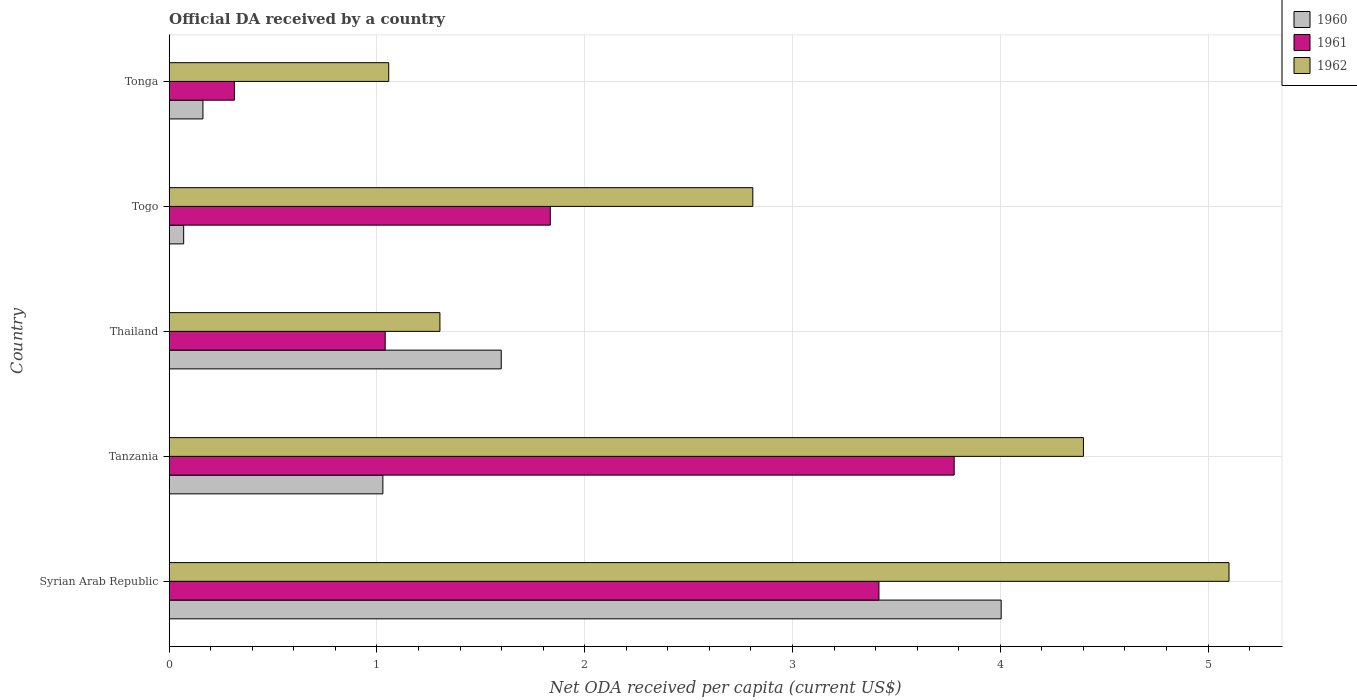Are the number of bars per tick equal to the number of legend labels?
Your response must be concise. Yes. Are the number of bars on each tick of the Y-axis equal?
Offer a terse response. Yes. What is the label of the 3rd group of bars from the top?
Keep it short and to the point. Thailand. What is the ODA received in in 1960 in Tonga?
Your response must be concise. 0.16. Across all countries, what is the maximum ODA received in in 1961?
Provide a short and direct response. 3.78. Across all countries, what is the minimum ODA received in in 1960?
Ensure brevity in your answer.  0.07. In which country was the ODA received in in 1960 maximum?
Offer a terse response. Syrian Arab Republic. In which country was the ODA received in in 1962 minimum?
Provide a succinct answer. Tonga. What is the total ODA received in in 1961 in the graph?
Provide a short and direct response. 10.38. What is the difference between the ODA received in in 1960 in Thailand and that in Tonga?
Your answer should be compact. 1.44. What is the difference between the ODA received in in 1962 in Tonga and the ODA received in in 1961 in Togo?
Offer a terse response. -0.78. What is the average ODA received in in 1960 per country?
Provide a succinct answer. 1.37. What is the difference between the ODA received in in 1961 and ODA received in in 1962 in Tonga?
Your response must be concise. -0.74. In how many countries, is the ODA received in in 1960 greater than 0.6000000000000001 US$?
Offer a very short reply. 3. What is the ratio of the ODA received in in 1961 in Syrian Arab Republic to that in Tanzania?
Offer a very short reply. 0.9. Is the ODA received in in 1962 in Syrian Arab Republic less than that in Togo?
Make the answer very short. No. What is the difference between the highest and the second highest ODA received in in 1960?
Offer a very short reply. 2.41. What is the difference between the highest and the lowest ODA received in in 1962?
Make the answer very short. 4.04. In how many countries, is the ODA received in in 1961 greater than the average ODA received in in 1961 taken over all countries?
Keep it short and to the point. 2. Are all the bars in the graph horizontal?
Ensure brevity in your answer.  Yes. How many countries are there in the graph?
Offer a very short reply. 5. Are the values on the major ticks of X-axis written in scientific E-notation?
Provide a short and direct response. No. Does the graph contain grids?
Offer a very short reply. Yes. How many legend labels are there?
Ensure brevity in your answer.  3. How are the legend labels stacked?
Ensure brevity in your answer.  Vertical. What is the title of the graph?
Offer a terse response. Official DA received by a country. What is the label or title of the X-axis?
Provide a short and direct response. Net ODA received per capita (current US$). What is the label or title of the Y-axis?
Ensure brevity in your answer.  Country. What is the Net ODA received per capita (current US$) of 1960 in Syrian Arab Republic?
Your answer should be very brief. 4. What is the Net ODA received per capita (current US$) of 1961 in Syrian Arab Republic?
Make the answer very short. 3.42. What is the Net ODA received per capita (current US$) in 1962 in Syrian Arab Republic?
Provide a succinct answer. 5.1. What is the Net ODA received per capita (current US$) in 1960 in Tanzania?
Ensure brevity in your answer.  1.03. What is the Net ODA received per capita (current US$) in 1961 in Tanzania?
Keep it short and to the point. 3.78. What is the Net ODA received per capita (current US$) of 1962 in Tanzania?
Provide a succinct answer. 4.4. What is the Net ODA received per capita (current US$) in 1960 in Thailand?
Ensure brevity in your answer.  1.6. What is the Net ODA received per capita (current US$) in 1961 in Thailand?
Give a very brief answer. 1.04. What is the Net ODA received per capita (current US$) in 1962 in Thailand?
Your answer should be compact. 1.3. What is the Net ODA received per capita (current US$) in 1960 in Togo?
Provide a short and direct response. 0.07. What is the Net ODA received per capita (current US$) in 1961 in Togo?
Make the answer very short. 1.83. What is the Net ODA received per capita (current US$) of 1962 in Togo?
Make the answer very short. 2.81. What is the Net ODA received per capita (current US$) in 1960 in Tonga?
Provide a succinct answer. 0.16. What is the Net ODA received per capita (current US$) in 1961 in Tonga?
Keep it short and to the point. 0.31. What is the Net ODA received per capita (current US$) in 1962 in Tonga?
Your answer should be very brief. 1.06. Across all countries, what is the maximum Net ODA received per capita (current US$) of 1960?
Provide a short and direct response. 4. Across all countries, what is the maximum Net ODA received per capita (current US$) of 1961?
Your answer should be compact. 3.78. Across all countries, what is the maximum Net ODA received per capita (current US$) of 1962?
Ensure brevity in your answer.  5.1. Across all countries, what is the minimum Net ODA received per capita (current US$) in 1960?
Keep it short and to the point. 0.07. Across all countries, what is the minimum Net ODA received per capita (current US$) of 1961?
Your answer should be compact. 0.31. Across all countries, what is the minimum Net ODA received per capita (current US$) in 1962?
Offer a very short reply. 1.06. What is the total Net ODA received per capita (current US$) in 1960 in the graph?
Provide a succinct answer. 6.86. What is the total Net ODA received per capita (current US$) in 1961 in the graph?
Provide a short and direct response. 10.38. What is the total Net ODA received per capita (current US$) of 1962 in the graph?
Provide a short and direct response. 14.67. What is the difference between the Net ODA received per capita (current US$) in 1960 in Syrian Arab Republic and that in Tanzania?
Offer a very short reply. 2.98. What is the difference between the Net ODA received per capita (current US$) of 1961 in Syrian Arab Republic and that in Tanzania?
Keep it short and to the point. -0.36. What is the difference between the Net ODA received per capita (current US$) of 1962 in Syrian Arab Republic and that in Tanzania?
Your response must be concise. 0.7. What is the difference between the Net ODA received per capita (current US$) of 1960 in Syrian Arab Republic and that in Thailand?
Offer a terse response. 2.41. What is the difference between the Net ODA received per capita (current US$) of 1961 in Syrian Arab Republic and that in Thailand?
Provide a succinct answer. 2.38. What is the difference between the Net ODA received per capita (current US$) of 1962 in Syrian Arab Republic and that in Thailand?
Offer a very short reply. 3.8. What is the difference between the Net ODA received per capita (current US$) of 1960 in Syrian Arab Republic and that in Togo?
Make the answer very short. 3.93. What is the difference between the Net ODA received per capita (current US$) of 1961 in Syrian Arab Republic and that in Togo?
Provide a short and direct response. 1.58. What is the difference between the Net ODA received per capita (current US$) of 1962 in Syrian Arab Republic and that in Togo?
Keep it short and to the point. 2.29. What is the difference between the Net ODA received per capita (current US$) in 1960 in Syrian Arab Republic and that in Tonga?
Make the answer very short. 3.84. What is the difference between the Net ODA received per capita (current US$) in 1961 in Syrian Arab Republic and that in Tonga?
Your answer should be compact. 3.1. What is the difference between the Net ODA received per capita (current US$) in 1962 in Syrian Arab Republic and that in Tonga?
Your response must be concise. 4.04. What is the difference between the Net ODA received per capita (current US$) of 1960 in Tanzania and that in Thailand?
Make the answer very short. -0.57. What is the difference between the Net ODA received per capita (current US$) of 1961 in Tanzania and that in Thailand?
Give a very brief answer. 2.74. What is the difference between the Net ODA received per capita (current US$) of 1962 in Tanzania and that in Thailand?
Make the answer very short. 3.1. What is the difference between the Net ODA received per capita (current US$) of 1960 in Tanzania and that in Togo?
Offer a very short reply. 0.96. What is the difference between the Net ODA received per capita (current US$) of 1961 in Tanzania and that in Togo?
Give a very brief answer. 1.94. What is the difference between the Net ODA received per capita (current US$) in 1962 in Tanzania and that in Togo?
Make the answer very short. 1.59. What is the difference between the Net ODA received per capita (current US$) in 1960 in Tanzania and that in Tonga?
Your answer should be very brief. 0.87. What is the difference between the Net ODA received per capita (current US$) of 1961 in Tanzania and that in Tonga?
Your answer should be compact. 3.46. What is the difference between the Net ODA received per capita (current US$) in 1962 in Tanzania and that in Tonga?
Make the answer very short. 3.34. What is the difference between the Net ODA received per capita (current US$) of 1960 in Thailand and that in Togo?
Your answer should be very brief. 1.53. What is the difference between the Net ODA received per capita (current US$) of 1961 in Thailand and that in Togo?
Ensure brevity in your answer.  -0.79. What is the difference between the Net ODA received per capita (current US$) in 1962 in Thailand and that in Togo?
Your answer should be compact. -1.51. What is the difference between the Net ODA received per capita (current US$) in 1960 in Thailand and that in Tonga?
Your answer should be compact. 1.44. What is the difference between the Net ODA received per capita (current US$) in 1961 in Thailand and that in Tonga?
Provide a succinct answer. 0.73. What is the difference between the Net ODA received per capita (current US$) of 1962 in Thailand and that in Tonga?
Your response must be concise. 0.25. What is the difference between the Net ODA received per capita (current US$) in 1960 in Togo and that in Tonga?
Your response must be concise. -0.09. What is the difference between the Net ODA received per capita (current US$) of 1961 in Togo and that in Tonga?
Your response must be concise. 1.52. What is the difference between the Net ODA received per capita (current US$) of 1962 in Togo and that in Tonga?
Keep it short and to the point. 1.75. What is the difference between the Net ODA received per capita (current US$) in 1960 in Syrian Arab Republic and the Net ODA received per capita (current US$) in 1961 in Tanzania?
Your answer should be very brief. 0.23. What is the difference between the Net ODA received per capita (current US$) in 1960 in Syrian Arab Republic and the Net ODA received per capita (current US$) in 1962 in Tanzania?
Ensure brevity in your answer.  -0.4. What is the difference between the Net ODA received per capita (current US$) in 1961 in Syrian Arab Republic and the Net ODA received per capita (current US$) in 1962 in Tanzania?
Keep it short and to the point. -0.98. What is the difference between the Net ODA received per capita (current US$) of 1960 in Syrian Arab Republic and the Net ODA received per capita (current US$) of 1961 in Thailand?
Ensure brevity in your answer.  2.96. What is the difference between the Net ODA received per capita (current US$) of 1960 in Syrian Arab Republic and the Net ODA received per capita (current US$) of 1962 in Thailand?
Keep it short and to the point. 2.7. What is the difference between the Net ODA received per capita (current US$) of 1961 in Syrian Arab Republic and the Net ODA received per capita (current US$) of 1962 in Thailand?
Your answer should be compact. 2.11. What is the difference between the Net ODA received per capita (current US$) in 1960 in Syrian Arab Republic and the Net ODA received per capita (current US$) in 1961 in Togo?
Make the answer very short. 2.17. What is the difference between the Net ODA received per capita (current US$) of 1960 in Syrian Arab Republic and the Net ODA received per capita (current US$) of 1962 in Togo?
Your response must be concise. 1.2. What is the difference between the Net ODA received per capita (current US$) in 1961 in Syrian Arab Republic and the Net ODA received per capita (current US$) in 1962 in Togo?
Offer a very short reply. 0.61. What is the difference between the Net ODA received per capita (current US$) of 1960 in Syrian Arab Republic and the Net ODA received per capita (current US$) of 1961 in Tonga?
Offer a terse response. 3.69. What is the difference between the Net ODA received per capita (current US$) of 1960 in Syrian Arab Republic and the Net ODA received per capita (current US$) of 1962 in Tonga?
Offer a terse response. 2.95. What is the difference between the Net ODA received per capita (current US$) in 1961 in Syrian Arab Republic and the Net ODA received per capita (current US$) in 1962 in Tonga?
Give a very brief answer. 2.36. What is the difference between the Net ODA received per capita (current US$) in 1960 in Tanzania and the Net ODA received per capita (current US$) in 1961 in Thailand?
Offer a terse response. -0.01. What is the difference between the Net ODA received per capita (current US$) of 1960 in Tanzania and the Net ODA received per capita (current US$) of 1962 in Thailand?
Give a very brief answer. -0.27. What is the difference between the Net ODA received per capita (current US$) of 1961 in Tanzania and the Net ODA received per capita (current US$) of 1962 in Thailand?
Your answer should be very brief. 2.48. What is the difference between the Net ODA received per capita (current US$) in 1960 in Tanzania and the Net ODA received per capita (current US$) in 1961 in Togo?
Give a very brief answer. -0.81. What is the difference between the Net ODA received per capita (current US$) in 1960 in Tanzania and the Net ODA received per capita (current US$) in 1962 in Togo?
Your answer should be very brief. -1.78. What is the difference between the Net ODA received per capita (current US$) in 1961 in Tanzania and the Net ODA received per capita (current US$) in 1962 in Togo?
Your response must be concise. 0.97. What is the difference between the Net ODA received per capita (current US$) in 1960 in Tanzania and the Net ODA received per capita (current US$) in 1961 in Tonga?
Give a very brief answer. 0.71. What is the difference between the Net ODA received per capita (current US$) of 1960 in Tanzania and the Net ODA received per capita (current US$) of 1962 in Tonga?
Your answer should be very brief. -0.03. What is the difference between the Net ODA received per capita (current US$) of 1961 in Tanzania and the Net ODA received per capita (current US$) of 1962 in Tonga?
Provide a succinct answer. 2.72. What is the difference between the Net ODA received per capita (current US$) in 1960 in Thailand and the Net ODA received per capita (current US$) in 1961 in Togo?
Make the answer very short. -0.24. What is the difference between the Net ODA received per capita (current US$) in 1960 in Thailand and the Net ODA received per capita (current US$) in 1962 in Togo?
Ensure brevity in your answer.  -1.21. What is the difference between the Net ODA received per capita (current US$) of 1961 in Thailand and the Net ODA received per capita (current US$) of 1962 in Togo?
Keep it short and to the point. -1.77. What is the difference between the Net ODA received per capita (current US$) in 1960 in Thailand and the Net ODA received per capita (current US$) in 1961 in Tonga?
Give a very brief answer. 1.28. What is the difference between the Net ODA received per capita (current US$) of 1960 in Thailand and the Net ODA received per capita (current US$) of 1962 in Tonga?
Give a very brief answer. 0.54. What is the difference between the Net ODA received per capita (current US$) of 1961 in Thailand and the Net ODA received per capita (current US$) of 1962 in Tonga?
Provide a short and direct response. -0.02. What is the difference between the Net ODA received per capita (current US$) in 1960 in Togo and the Net ODA received per capita (current US$) in 1961 in Tonga?
Ensure brevity in your answer.  -0.24. What is the difference between the Net ODA received per capita (current US$) of 1960 in Togo and the Net ODA received per capita (current US$) of 1962 in Tonga?
Offer a very short reply. -0.99. What is the difference between the Net ODA received per capita (current US$) in 1961 in Togo and the Net ODA received per capita (current US$) in 1962 in Tonga?
Give a very brief answer. 0.78. What is the average Net ODA received per capita (current US$) in 1960 per country?
Your answer should be compact. 1.37. What is the average Net ODA received per capita (current US$) in 1961 per country?
Give a very brief answer. 2.08. What is the average Net ODA received per capita (current US$) of 1962 per country?
Offer a very short reply. 2.93. What is the difference between the Net ODA received per capita (current US$) in 1960 and Net ODA received per capita (current US$) in 1961 in Syrian Arab Republic?
Provide a short and direct response. 0.59. What is the difference between the Net ODA received per capita (current US$) of 1960 and Net ODA received per capita (current US$) of 1962 in Syrian Arab Republic?
Offer a terse response. -1.1. What is the difference between the Net ODA received per capita (current US$) of 1961 and Net ODA received per capita (current US$) of 1962 in Syrian Arab Republic?
Your answer should be very brief. -1.68. What is the difference between the Net ODA received per capita (current US$) of 1960 and Net ODA received per capita (current US$) of 1961 in Tanzania?
Make the answer very short. -2.75. What is the difference between the Net ODA received per capita (current US$) in 1960 and Net ODA received per capita (current US$) in 1962 in Tanzania?
Your answer should be very brief. -3.37. What is the difference between the Net ODA received per capita (current US$) of 1961 and Net ODA received per capita (current US$) of 1962 in Tanzania?
Ensure brevity in your answer.  -0.62. What is the difference between the Net ODA received per capita (current US$) of 1960 and Net ODA received per capita (current US$) of 1961 in Thailand?
Keep it short and to the point. 0.56. What is the difference between the Net ODA received per capita (current US$) in 1960 and Net ODA received per capita (current US$) in 1962 in Thailand?
Offer a terse response. 0.3. What is the difference between the Net ODA received per capita (current US$) in 1961 and Net ODA received per capita (current US$) in 1962 in Thailand?
Offer a very short reply. -0.26. What is the difference between the Net ODA received per capita (current US$) in 1960 and Net ODA received per capita (current US$) in 1961 in Togo?
Offer a very short reply. -1.76. What is the difference between the Net ODA received per capita (current US$) in 1960 and Net ODA received per capita (current US$) in 1962 in Togo?
Your answer should be very brief. -2.74. What is the difference between the Net ODA received per capita (current US$) in 1961 and Net ODA received per capita (current US$) in 1962 in Togo?
Ensure brevity in your answer.  -0.97. What is the difference between the Net ODA received per capita (current US$) of 1960 and Net ODA received per capita (current US$) of 1961 in Tonga?
Offer a terse response. -0.15. What is the difference between the Net ODA received per capita (current US$) of 1960 and Net ODA received per capita (current US$) of 1962 in Tonga?
Ensure brevity in your answer.  -0.89. What is the difference between the Net ODA received per capita (current US$) in 1961 and Net ODA received per capita (current US$) in 1962 in Tonga?
Offer a terse response. -0.74. What is the ratio of the Net ODA received per capita (current US$) of 1960 in Syrian Arab Republic to that in Tanzania?
Offer a very short reply. 3.89. What is the ratio of the Net ODA received per capita (current US$) in 1961 in Syrian Arab Republic to that in Tanzania?
Ensure brevity in your answer.  0.9. What is the ratio of the Net ODA received per capita (current US$) in 1962 in Syrian Arab Republic to that in Tanzania?
Provide a succinct answer. 1.16. What is the ratio of the Net ODA received per capita (current US$) of 1960 in Syrian Arab Republic to that in Thailand?
Offer a terse response. 2.51. What is the ratio of the Net ODA received per capita (current US$) in 1961 in Syrian Arab Republic to that in Thailand?
Give a very brief answer. 3.29. What is the ratio of the Net ODA received per capita (current US$) of 1962 in Syrian Arab Republic to that in Thailand?
Keep it short and to the point. 3.91. What is the ratio of the Net ODA received per capita (current US$) in 1960 in Syrian Arab Republic to that in Togo?
Give a very brief answer. 57.53. What is the ratio of the Net ODA received per capita (current US$) in 1961 in Syrian Arab Republic to that in Togo?
Your response must be concise. 1.86. What is the ratio of the Net ODA received per capita (current US$) in 1962 in Syrian Arab Republic to that in Togo?
Offer a terse response. 1.82. What is the ratio of the Net ODA received per capita (current US$) in 1960 in Syrian Arab Republic to that in Tonga?
Provide a succinct answer. 24.67. What is the ratio of the Net ODA received per capita (current US$) of 1961 in Syrian Arab Republic to that in Tonga?
Offer a very short reply. 10.89. What is the ratio of the Net ODA received per capita (current US$) in 1962 in Syrian Arab Republic to that in Tonga?
Give a very brief answer. 4.83. What is the ratio of the Net ODA received per capita (current US$) of 1960 in Tanzania to that in Thailand?
Your answer should be very brief. 0.64. What is the ratio of the Net ODA received per capita (current US$) in 1961 in Tanzania to that in Thailand?
Provide a short and direct response. 3.63. What is the ratio of the Net ODA received per capita (current US$) of 1962 in Tanzania to that in Thailand?
Provide a short and direct response. 3.38. What is the ratio of the Net ODA received per capita (current US$) of 1960 in Tanzania to that in Togo?
Your answer should be compact. 14.78. What is the ratio of the Net ODA received per capita (current US$) in 1961 in Tanzania to that in Togo?
Give a very brief answer. 2.06. What is the ratio of the Net ODA received per capita (current US$) of 1962 in Tanzania to that in Togo?
Your answer should be very brief. 1.57. What is the ratio of the Net ODA received per capita (current US$) of 1960 in Tanzania to that in Tonga?
Give a very brief answer. 6.33. What is the ratio of the Net ODA received per capita (current US$) in 1961 in Tanzania to that in Tonga?
Ensure brevity in your answer.  12.04. What is the ratio of the Net ODA received per capita (current US$) in 1962 in Tanzania to that in Tonga?
Provide a succinct answer. 4.16. What is the ratio of the Net ODA received per capita (current US$) in 1960 in Thailand to that in Togo?
Provide a succinct answer. 22.96. What is the ratio of the Net ODA received per capita (current US$) in 1961 in Thailand to that in Togo?
Keep it short and to the point. 0.57. What is the ratio of the Net ODA received per capita (current US$) of 1962 in Thailand to that in Togo?
Provide a short and direct response. 0.46. What is the ratio of the Net ODA received per capita (current US$) of 1960 in Thailand to that in Tonga?
Give a very brief answer. 9.84. What is the ratio of the Net ODA received per capita (current US$) of 1961 in Thailand to that in Tonga?
Provide a short and direct response. 3.31. What is the ratio of the Net ODA received per capita (current US$) of 1962 in Thailand to that in Tonga?
Give a very brief answer. 1.23. What is the ratio of the Net ODA received per capita (current US$) in 1960 in Togo to that in Tonga?
Offer a terse response. 0.43. What is the ratio of the Net ODA received per capita (current US$) in 1961 in Togo to that in Tonga?
Your answer should be very brief. 5.85. What is the ratio of the Net ODA received per capita (current US$) in 1962 in Togo to that in Tonga?
Offer a very short reply. 2.66. What is the difference between the highest and the second highest Net ODA received per capita (current US$) in 1960?
Provide a short and direct response. 2.41. What is the difference between the highest and the second highest Net ODA received per capita (current US$) of 1961?
Provide a short and direct response. 0.36. What is the difference between the highest and the second highest Net ODA received per capita (current US$) in 1962?
Make the answer very short. 0.7. What is the difference between the highest and the lowest Net ODA received per capita (current US$) of 1960?
Provide a short and direct response. 3.93. What is the difference between the highest and the lowest Net ODA received per capita (current US$) of 1961?
Offer a terse response. 3.46. What is the difference between the highest and the lowest Net ODA received per capita (current US$) of 1962?
Your answer should be very brief. 4.04. 